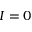<formula> <loc_0><loc_0><loc_500><loc_500>{ I = 0 }</formula> 